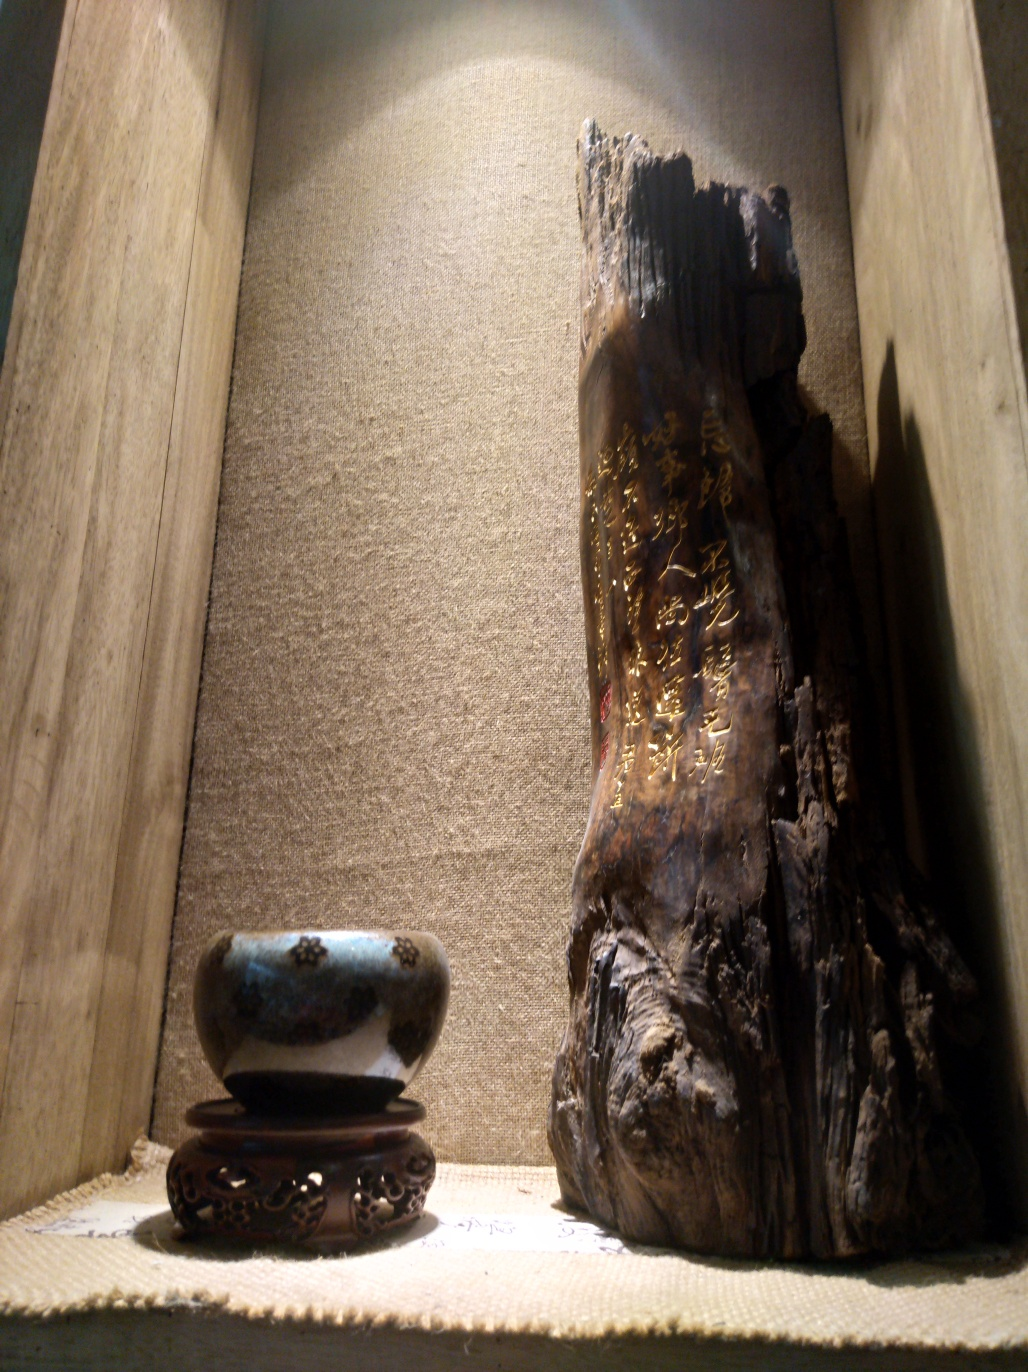Can you tell me more about the lighting and how it affects the appearance of the items? The lighting in the image is directed from above, casting a soft glow that emphasizes the height and contours of the wooden carving, while also bringing out the subtle luster of the ceramic bowl. This strategic illumination not only reveals the textural nuances of both pieces but also creates an ambience that resonates with warmth and contemplation. 